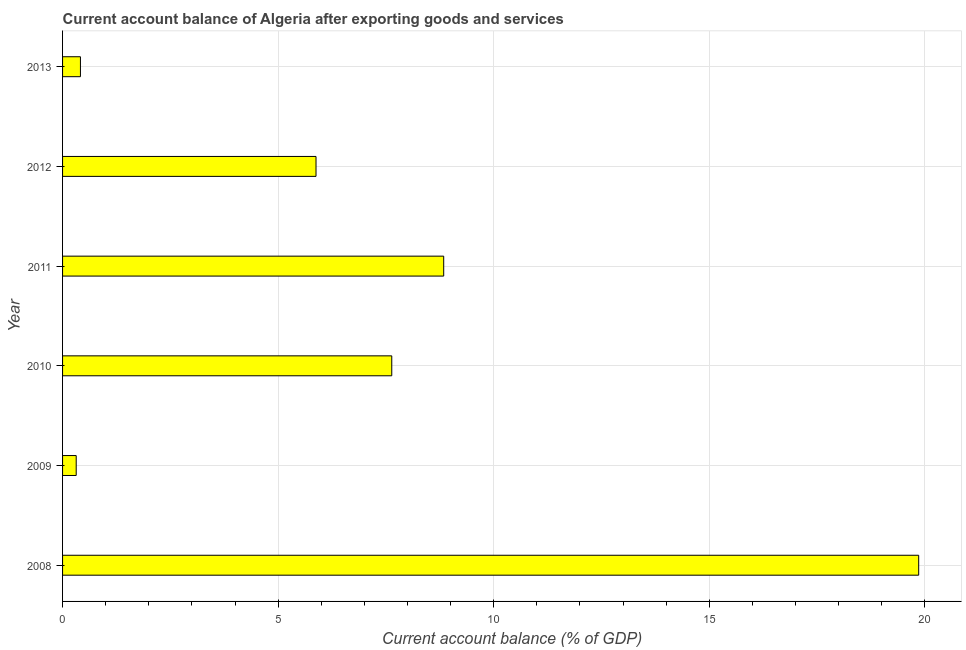What is the title of the graph?
Provide a succinct answer. Current account balance of Algeria after exporting goods and services. What is the label or title of the X-axis?
Offer a very short reply. Current account balance (% of GDP). What is the label or title of the Y-axis?
Offer a very short reply. Year. What is the current account balance in 2010?
Give a very brief answer. 7.64. Across all years, what is the maximum current account balance?
Make the answer very short. 19.86. Across all years, what is the minimum current account balance?
Ensure brevity in your answer.  0.32. In which year was the current account balance minimum?
Your response must be concise. 2009. What is the sum of the current account balance?
Ensure brevity in your answer.  42.94. What is the difference between the current account balance in 2012 and 2013?
Keep it short and to the point. 5.46. What is the average current account balance per year?
Make the answer very short. 7.16. What is the median current account balance?
Give a very brief answer. 6.76. In how many years, is the current account balance greater than 12 %?
Your answer should be compact. 1. What is the ratio of the current account balance in 2009 to that in 2010?
Your answer should be compact. 0.04. Is the current account balance in 2011 less than that in 2013?
Provide a short and direct response. No. Is the difference between the current account balance in 2008 and 2013 greater than the difference between any two years?
Provide a short and direct response. No. What is the difference between the highest and the second highest current account balance?
Make the answer very short. 11.02. Is the sum of the current account balance in 2008 and 2010 greater than the maximum current account balance across all years?
Your response must be concise. Yes. What is the difference between the highest and the lowest current account balance?
Your answer should be very brief. 19.54. How many bars are there?
Your answer should be compact. 6. What is the Current account balance (% of GDP) in 2008?
Your answer should be compact. 19.86. What is the Current account balance (% of GDP) in 2009?
Keep it short and to the point. 0.32. What is the Current account balance (% of GDP) of 2010?
Provide a succinct answer. 7.64. What is the Current account balance (% of GDP) in 2011?
Give a very brief answer. 8.84. What is the Current account balance (% of GDP) in 2012?
Provide a succinct answer. 5.88. What is the Current account balance (% of GDP) in 2013?
Your response must be concise. 0.41. What is the difference between the Current account balance (% of GDP) in 2008 and 2009?
Keep it short and to the point. 19.54. What is the difference between the Current account balance (% of GDP) in 2008 and 2010?
Your answer should be very brief. 12.22. What is the difference between the Current account balance (% of GDP) in 2008 and 2011?
Your answer should be compact. 11.02. What is the difference between the Current account balance (% of GDP) in 2008 and 2012?
Ensure brevity in your answer.  13.98. What is the difference between the Current account balance (% of GDP) in 2008 and 2013?
Make the answer very short. 19.44. What is the difference between the Current account balance (% of GDP) in 2009 and 2010?
Provide a short and direct response. -7.32. What is the difference between the Current account balance (% of GDP) in 2009 and 2011?
Provide a short and direct response. -8.52. What is the difference between the Current account balance (% of GDP) in 2009 and 2012?
Your response must be concise. -5.56. What is the difference between the Current account balance (% of GDP) in 2009 and 2013?
Provide a succinct answer. -0.1. What is the difference between the Current account balance (% of GDP) in 2010 and 2011?
Offer a terse response. -1.2. What is the difference between the Current account balance (% of GDP) in 2010 and 2012?
Your response must be concise. 1.76. What is the difference between the Current account balance (% of GDP) in 2010 and 2013?
Make the answer very short. 7.22. What is the difference between the Current account balance (% of GDP) in 2011 and 2012?
Your answer should be very brief. 2.96. What is the difference between the Current account balance (% of GDP) in 2011 and 2013?
Keep it short and to the point. 8.43. What is the difference between the Current account balance (% of GDP) in 2012 and 2013?
Keep it short and to the point. 5.46. What is the ratio of the Current account balance (% of GDP) in 2008 to that in 2009?
Offer a terse response. 62.78. What is the ratio of the Current account balance (% of GDP) in 2008 to that in 2010?
Offer a very short reply. 2.6. What is the ratio of the Current account balance (% of GDP) in 2008 to that in 2011?
Offer a terse response. 2.25. What is the ratio of the Current account balance (% of GDP) in 2008 to that in 2012?
Your answer should be compact. 3.38. What is the ratio of the Current account balance (% of GDP) in 2008 to that in 2013?
Your answer should be compact. 47.9. What is the ratio of the Current account balance (% of GDP) in 2009 to that in 2010?
Provide a succinct answer. 0.04. What is the ratio of the Current account balance (% of GDP) in 2009 to that in 2011?
Ensure brevity in your answer.  0.04. What is the ratio of the Current account balance (% of GDP) in 2009 to that in 2012?
Your answer should be very brief. 0.05. What is the ratio of the Current account balance (% of GDP) in 2009 to that in 2013?
Provide a short and direct response. 0.76. What is the ratio of the Current account balance (% of GDP) in 2010 to that in 2011?
Keep it short and to the point. 0.86. What is the ratio of the Current account balance (% of GDP) in 2010 to that in 2012?
Give a very brief answer. 1.3. What is the ratio of the Current account balance (% of GDP) in 2010 to that in 2013?
Offer a terse response. 18.42. What is the ratio of the Current account balance (% of GDP) in 2011 to that in 2012?
Ensure brevity in your answer.  1.5. What is the ratio of the Current account balance (% of GDP) in 2011 to that in 2013?
Make the answer very short. 21.33. What is the ratio of the Current account balance (% of GDP) in 2012 to that in 2013?
Provide a succinct answer. 14.18. 